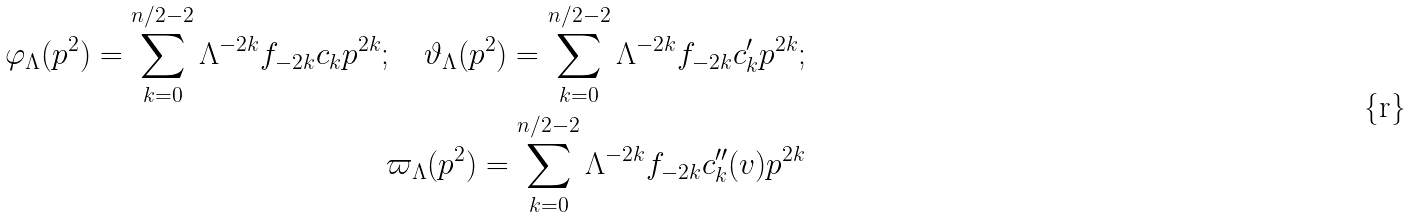<formula> <loc_0><loc_0><loc_500><loc_500>\varphi _ { \Lambda } ( p ^ { 2 } ) = \sum _ { k = 0 } ^ { n / 2 - 2 } \Lambda ^ { - 2 k } f _ { - 2 k } c _ { k } p ^ { 2 k } ; \quad \vartheta _ { \Lambda } ( p ^ { 2 } ) = \sum _ { k = 0 } ^ { n / 2 - 2 } \Lambda ^ { - 2 k } f _ { - 2 k } c _ { k } ^ { \prime } p ^ { 2 k } ; \\ \varpi _ { \Lambda } ( p ^ { 2 } ) = \sum _ { k = 0 } ^ { n / 2 - 2 } \Lambda ^ { - 2 k } f _ { - 2 k } c _ { k } ^ { \prime \prime } ( v ) p ^ { 2 k }</formula> 